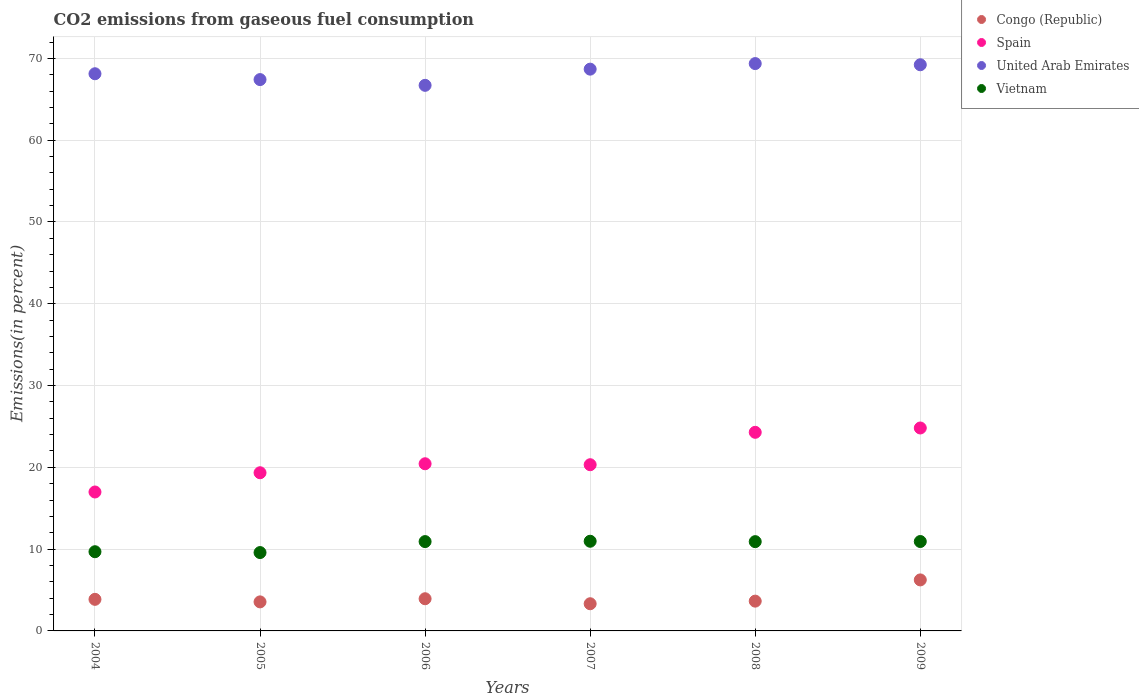What is the total CO2 emitted in Vietnam in 2006?
Your answer should be very brief. 10.92. Across all years, what is the maximum total CO2 emitted in Spain?
Your answer should be very brief. 24.81. Across all years, what is the minimum total CO2 emitted in United Arab Emirates?
Offer a terse response. 66.7. In which year was the total CO2 emitted in United Arab Emirates minimum?
Keep it short and to the point. 2006. What is the total total CO2 emitted in Spain in the graph?
Your response must be concise. 126.17. What is the difference between the total CO2 emitted in Spain in 2004 and that in 2009?
Keep it short and to the point. -7.83. What is the difference between the total CO2 emitted in Spain in 2006 and the total CO2 emitted in Vietnam in 2008?
Your answer should be very brief. 9.52. What is the average total CO2 emitted in Spain per year?
Give a very brief answer. 21.03. In the year 2008, what is the difference between the total CO2 emitted in Congo (Republic) and total CO2 emitted in United Arab Emirates?
Make the answer very short. -65.72. In how many years, is the total CO2 emitted in Congo (Republic) greater than 56 %?
Give a very brief answer. 0. What is the ratio of the total CO2 emitted in Congo (Republic) in 2007 to that in 2008?
Give a very brief answer. 0.91. What is the difference between the highest and the second highest total CO2 emitted in Vietnam?
Provide a short and direct response. 0.03. What is the difference between the highest and the lowest total CO2 emitted in Spain?
Offer a very short reply. 7.83. Is the sum of the total CO2 emitted in Congo (Republic) in 2006 and 2008 greater than the maximum total CO2 emitted in United Arab Emirates across all years?
Ensure brevity in your answer.  No. Is it the case that in every year, the sum of the total CO2 emitted in Vietnam and total CO2 emitted in Spain  is greater than the sum of total CO2 emitted in Congo (Republic) and total CO2 emitted in United Arab Emirates?
Your response must be concise. No. Does the total CO2 emitted in Congo (Republic) monotonically increase over the years?
Offer a terse response. No. Is the total CO2 emitted in Congo (Republic) strictly less than the total CO2 emitted in United Arab Emirates over the years?
Your answer should be very brief. Yes. How many years are there in the graph?
Ensure brevity in your answer.  6. What is the difference between two consecutive major ticks on the Y-axis?
Keep it short and to the point. 10. Does the graph contain grids?
Make the answer very short. Yes. How many legend labels are there?
Make the answer very short. 4. What is the title of the graph?
Provide a short and direct response. CO2 emissions from gaseous fuel consumption. What is the label or title of the Y-axis?
Make the answer very short. Emissions(in percent). What is the Emissions(in percent) in Congo (Republic) in 2004?
Keep it short and to the point. 3.86. What is the Emissions(in percent) of Spain in 2004?
Make the answer very short. 16.99. What is the Emissions(in percent) of United Arab Emirates in 2004?
Your answer should be very brief. 68.12. What is the Emissions(in percent) of Vietnam in 2004?
Give a very brief answer. 9.68. What is the Emissions(in percent) in Congo (Republic) in 2005?
Your answer should be very brief. 3.55. What is the Emissions(in percent) of Spain in 2005?
Provide a short and direct response. 19.34. What is the Emissions(in percent) of United Arab Emirates in 2005?
Keep it short and to the point. 67.41. What is the Emissions(in percent) of Vietnam in 2005?
Your response must be concise. 9.58. What is the Emissions(in percent) of Congo (Republic) in 2006?
Your response must be concise. 3.93. What is the Emissions(in percent) of Spain in 2006?
Your response must be concise. 20.44. What is the Emissions(in percent) of United Arab Emirates in 2006?
Provide a short and direct response. 66.7. What is the Emissions(in percent) of Vietnam in 2006?
Your response must be concise. 10.92. What is the Emissions(in percent) of Congo (Republic) in 2007?
Your answer should be compact. 3.32. What is the Emissions(in percent) in Spain in 2007?
Keep it short and to the point. 20.32. What is the Emissions(in percent) of United Arab Emirates in 2007?
Provide a short and direct response. 68.68. What is the Emissions(in percent) of Vietnam in 2007?
Your response must be concise. 10.96. What is the Emissions(in percent) of Congo (Republic) in 2008?
Keep it short and to the point. 3.64. What is the Emissions(in percent) of Spain in 2008?
Your response must be concise. 24.28. What is the Emissions(in percent) in United Arab Emirates in 2008?
Keep it short and to the point. 69.36. What is the Emissions(in percent) of Vietnam in 2008?
Offer a very short reply. 10.91. What is the Emissions(in percent) in Congo (Republic) in 2009?
Your answer should be very brief. 6.24. What is the Emissions(in percent) of Spain in 2009?
Offer a terse response. 24.81. What is the Emissions(in percent) of United Arab Emirates in 2009?
Offer a terse response. 69.22. What is the Emissions(in percent) in Vietnam in 2009?
Make the answer very short. 10.93. Across all years, what is the maximum Emissions(in percent) of Congo (Republic)?
Give a very brief answer. 6.24. Across all years, what is the maximum Emissions(in percent) in Spain?
Your response must be concise. 24.81. Across all years, what is the maximum Emissions(in percent) in United Arab Emirates?
Offer a terse response. 69.36. Across all years, what is the maximum Emissions(in percent) in Vietnam?
Make the answer very short. 10.96. Across all years, what is the minimum Emissions(in percent) of Congo (Republic)?
Your answer should be compact. 3.32. Across all years, what is the minimum Emissions(in percent) in Spain?
Provide a short and direct response. 16.99. Across all years, what is the minimum Emissions(in percent) in United Arab Emirates?
Your response must be concise. 66.7. Across all years, what is the minimum Emissions(in percent) of Vietnam?
Ensure brevity in your answer.  9.58. What is the total Emissions(in percent) in Congo (Republic) in the graph?
Offer a terse response. 24.55. What is the total Emissions(in percent) of Spain in the graph?
Your answer should be compact. 126.17. What is the total Emissions(in percent) of United Arab Emirates in the graph?
Offer a very short reply. 409.49. What is the total Emissions(in percent) of Vietnam in the graph?
Your response must be concise. 62.99. What is the difference between the Emissions(in percent) of Congo (Republic) in 2004 and that in 2005?
Make the answer very short. 0.31. What is the difference between the Emissions(in percent) in Spain in 2004 and that in 2005?
Provide a succinct answer. -2.35. What is the difference between the Emissions(in percent) of United Arab Emirates in 2004 and that in 2005?
Ensure brevity in your answer.  0.71. What is the difference between the Emissions(in percent) of Vietnam in 2004 and that in 2005?
Provide a short and direct response. 0.1. What is the difference between the Emissions(in percent) in Congo (Republic) in 2004 and that in 2006?
Your response must be concise. -0.07. What is the difference between the Emissions(in percent) of Spain in 2004 and that in 2006?
Your answer should be compact. -3.45. What is the difference between the Emissions(in percent) in United Arab Emirates in 2004 and that in 2006?
Give a very brief answer. 1.42. What is the difference between the Emissions(in percent) in Vietnam in 2004 and that in 2006?
Offer a terse response. -1.24. What is the difference between the Emissions(in percent) of Congo (Republic) in 2004 and that in 2007?
Your answer should be very brief. 0.54. What is the difference between the Emissions(in percent) of Spain in 2004 and that in 2007?
Keep it short and to the point. -3.33. What is the difference between the Emissions(in percent) of United Arab Emirates in 2004 and that in 2007?
Ensure brevity in your answer.  -0.56. What is the difference between the Emissions(in percent) of Vietnam in 2004 and that in 2007?
Offer a very short reply. -1.28. What is the difference between the Emissions(in percent) of Congo (Republic) in 2004 and that in 2008?
Ensure brevity in your answer.  0.22. What is the difference between the Emissions(in percent) of Spain in 2004 and that in 2008?
Give a very brief answer. -7.3. What is the difference between the Emissions(in percent) of United Arab Emirates in 2004 and that in 2008?
Your response must be concise. -1.24. What is the difference between the Emissions(in percent) of Vietnam in 2004 and that in 2008?
Offer a very short reply. -1.23. What is the difference between the Emissions(in percent) of Congo (Republic) in 2004 and that in 2009?
Offer a very short reply. -2.38. What is the difference between the Emissions(in percent) of Spain in 2004 and that in 2009?
Your answer should be compact. -7.83. What is the difference between the Emissions(in percent) of United Arab Emirates in 2004 and that in 2009?
Offer a very short reply. -1.1. What is the difference between the Emissions(in percent) in Vietnam in 2004 and that in 2009?
Offer a terse response. -1.25. What is the difference between the Emissions(in percent) of Congo (Republic) in 2005 and that in 2006?
Provide a short and direct response. -0.38. What is the difference between the Emissions(in percent) in Spain in 2005 and that in 2006?
Give a very brief answer. -1.1. What is the difference between the Emissions(in percent) in United Arab Emirates in 2005 and that in 2006?
Keep it short and to the point. 0.7. What is the difference between the Emissions(in percent) of Vietnam in 2005 and that in 2006?
Provide a short and direct response. -1.34. What is the difference between the Emissions(in percent) in Congo (Republic) in 2005 and that in 2007?
Keep it short and to the point. 0.23. What is the difference between the Emissions(in percent) in Spain in 2005 and that in 2007?
Your answer should be compact. -0.98. What is the difference between the Emissions(in percent) in United Arab Emirates in 2005 and that in 2007?
Make the answer very short. -1.28. What is the difference between the Emissions(in percent) in Vietnam in 2005 and that in 2007?
Your answer should be compact. -1.38. What is the difference between the Emissions(in percent) of Congo (Republic) in 2005 and that in 2008?
Your answer should be compact. -0.09. What is the difference between the Emissions(in percent) in Spain in 2005 and that in 2008?
Offer a terse response. -4.94. What is the difference between the Emissions(in percent) in United Arab Emirates in 2005 and that in 2008?
Make the answer very short. -1.96. What is the difference between the Emissions(in percent) in Vietnam in 2005 and that in 2008?
Give a very brief answer. -1.33. What is the difference between the Emissions(in percent) of Congo (Republic) in 2005 and that in 2009?
Your answer should be compact. -2.69. What is the difference between the Emissions(in percent) of Spain in 2005 and that in 2009?
Provide a short and direct response. -5.47. What is the difference between the Emissions(in percent) of United Arab Emirates in 2005 and that in 2009?
Keep it short and to the point. -1.81. What is the difference between the Emissions(in percent) in Vietnam in 2005 and that in 2009?
Provide a succinct answer. -1.35. What is the difference between the Emissions(in percent) of Congo (Republic) in 2006 and that in 2007?
Give a very brief answer. 0.61. What is the difference between the Emissions(in percent) in Spain in 2006 and that in 2007?
Your answer should be very brief. 0.12. What is the difference between the Emissions(in percent) in United Arab Emirates in 2006 and that in 2007?
Provide a succinct answer. -1.98. What is the difference between the Emissions(in percent) in Vietnam in 2006 and that in 2007?
Your answer should be compact. -0.04. What is the difference between the Emissions(in percent) in Congo (Republic) in 2006 and that in 2008?
Ensure brevity in your answer.  0.29. What is the difference between the Emissions(in percent) in Spain in 2006 and that in 2008?
Your answer should be compact. -3.85. What is the difference between the Emissions(in percent) of United Arab Emirates in 2006 and that in 2008?
Provide a succinct answer. -2.66. What is the difference between the Emissions(in percent) in Vietnam in 2006 and that in 2008?
Give a very brief answer. 0.01. What is the difference between the Emissions(in percent) of Congo (Republic) in 2006 and that in 2009?
Offer a terse response. -2.3. What is the difference between the Emissions(in percent) in Spain in 2006 and that in 2009?
Your answer should be compact. -4.37. What is the difference between the Emissions(in percent) of United Arab Emirates in 2006 and that in 2009?
Your response must be concise. -2.52. What is the difference between the Emissions(in percent) of Vietnam in 2006 and that in 2009?
Keep it short and to the point. -0.01. What is the difference between the Emissions(in percent) in Congo (Republic) in 2007 and that in 2008?
Keep it short and to the point. -0.32. What is the difference between the Emissions(in percent) of Spain in 2007 and that in 2008?
Ensure brevity in your answer.  -3.96. What is the difference between the Emissions(in percent) of United Arab Emirates in 2007 and that in 2008?
Make the answer very short. -0.68. What is the difference between the Emissions(in percent) of Vietnam in 2007 and that in 2008?
Offer a very short reply. 0.05. What is the difference between the Emissions(in percent) of Congo (Republic) in 2007 and that in 2009?
Provide a succinct answer. -2.91. What is the difference between the Emissions(in percent) in Spain in 2007 and that in 2009?
Make the answer very short. -4.49. What is the difference between the Emissions(in percent) in United Arab Emirates in 2007 and that in 2009?
Give a very brief answer. -0.54. What is the difference between the Emissions(in percent) in Vietnam in 2007 and that in 2009?
Your response must be concise. 0.03. What is the difference between the Emissions(in percent) of Congo (Republic) in 2008 and that in 2009?
Your response must be concise. -2.6. What is the difference between the Emissions(in percent) of Spain in 2008 and that in 2009?
Provide a succinct answer. -0.53. What is the difference between the Emissions(in percent) of United Arab Emirates in 2008 and that in 2009?
Offer a very short reply. 0.14. What is the difference between the Emissions(in percent) in Vietnam in 2008 and that in 2009?
Provide a short and direct response. -0.02. What is the difference between the Emissions(in percent) of Congo (Republic) in 2004 and the Emissions(in percent) of Spain in 2005?
Your response must be concise. -15.48. What is the difference between the Emissions(in percent) of Congo (Republic) in 2004 and the Emissions(in percent) of United Arab Emirates in 2005?
Your response must be concise. -63.54. What is the difference between the Emissions(in percent) in Congo (Republic) in 2004 and the Emissions(in percent) in Vietnam in 2005?
Provide a succinct answer. -5.72. What is the difference between the Emissions(in percent) in Spain in 2004 and the Emissions(in percent) in United Arab Emirates in 2005?
Your answer should be compact. -50.42. What is the difference between the Emissions(in percent) of Spain in 2004 and the Emissions(in percent) of Vietnam in 2005?
Offer a very short reply. 7.41. What is the difference between the Emissions(in percent) of United Arab Emirates in 2004 and the Emissions(in percent) of Vietnam in 2005?
Make the answer very short. 58.54. What is the difference between the Emissions(in percent) of Congo (Republic) in 2004 and the Emissions(in percent) of Spain in 2006?
Provide a succinct answer. -16.58. What is the difference between the Emissions(in percent) of Congo (Republic) in 2004 and the Emissions(in percent) of United Arab Emirates in 2006?
Provide a short and direct response. -62.84. What is the difference between the Emissions(in percent) of Congo (Republic) in 2004 and the Emissions(in percent) of Vietnam in 2006?
Give a very brief answer. -7.06. What is the difference between the Emissions(in percent) of Spain in 2004 and the Emissions(in percent) of United Arab Emirates in 2006?
Provide a succinct answer. -49.72. What is the difference between the Emissions(in percent) of Spain in 2004 and the Emissions(in percent) of Vietnam in 2006?
Keep it short and to the point. 6.06. What is the difference between the Emissions(in percent) in United Arab Emirates in 2004 and the Emissions(in percent) in Vietnam in 2006?
Provide a short and direct response. 57.2. What is the difference between the Emissions(in percent) in Congo (Republic) in 2004 and the Emissions(in percent) in Spain in 2007?
Your response must be concise. -16.46. What is the difference between the Emissions(in percent) in Congo (Republic) in 2004 and the Emissions(in percent) in United Arab Emirates in 2007?
Keep it short and to the point. -64.82. What is the difference between the Emissions(in percent) in Congo (Republic) in 2004 and the Emissions(in percent) in Vietnam in 2007?
Provide a short and direct response. -7.1. What is the difference between the Emissions(in percent) in Spain in 2004 and the Emissions(in percent) in United Arab Emirates in 2007?
Offer a very short reply. -51.7. What is the difference between the Emissions(in percent) in Spain in 2004 and the Emissions(in percent) in Vietnam in 2007?
Your response must be concise. 6.02. What is the difference between the Emissions(in percent) in United Arab Emirates in 2004 and the Emissions(in percent) in Vietnam in 2007?
Provide a succinct answer. 57.16. What is the difference between the Emissions(in percent) in Congo (Republic) in 2004 and the Emissions(in percent) in Spain in 2008?
Make the answer very short. -20.42. What is the difference between the Emissions(in percent) in Congo (Republic) in 2004 and the Emissions(in percent) in United Arab Emirates in 2008?
Your response must be concise. -65.5. What is the difference between the Emissions(in percent) of Congo (Republic) in 2004 and the Emissions(in percent) of Vietnam in 2008?
Ensure brevity in your answer.  -7.05. What is the difference between the Emissions(in percent) in Spain in 2004 and the Emissions(in percent) in United Arab Emirates in 2008?
Keep it short and to the point. -52.38. What is the difference between the Emissions(in percent) in Spain in 2004 and the Emissions(in percent) in Vietnam in 2008?
Provide a short and direct response. 6.07. What is the difference between the Emissions(in percent) in United Arab Emirates in 2004 and the Emissions(in percent) in Vietnam in 2008?
Make the answer very short. 57.2. What is the difference between the Emissions(in percent) in Congo (Republic) in 2004 and the Emissions(in percent) in Spain in 2009?
Provide a succinct answer. -20.95. What is the difference between the Emissions(in percent) of Congo (Republic) in 2004 and the Emissions(in percent) of United Arab Emirates in 2009?
Your answer should be very brief. -65.36. What is the difference between the Emissions(in percent) of Congo (Republic) in 2004 and the Emissions(in percent) of Vietnam in 2009?
Make the answer very short. -7.07. What is the difference between the Emissions(in percent) in Spain in 2004 and the Emissions(in percent) in United Arab Emirates in 2009?
Provide a succinct answer. -52.23. What is the difference between the Emissions(in percent) in Spain in 2004 and the Emissions(in percent) in Vietnam in 2009?
Offer a very short reply. 6.05. What is the difference between the Emissions(in percent) of United Arab Emirates in 2004 and the Emissions(in percent) of Vietnam in 2009?
Your response must be concise. 57.19. What is the difference between the Emissions(in percent) of Congo (Republic) in 2005 and the Emissions(in percent) of Spain in 2006?
Your response must be concise. -16.89. What is the difference between the Emissions(in percent) of Congo (Republic) in 2005 and the Emissions(in percent) of United Arab Emirates in 2006?
Provide a short and direct response. -63.15. What is the difference between the Emissions(in percent) of Congo (Republic) in 2005 and the Emissions(in percent) of Vietnam in 2006?
Keep it short and to the point. -7.37. What is the difference between the Emissions(in percent) in Spain in 2005 and the Emissions(in percent) in United Arab Emirates in 2006?
Ensure brevity in your answer.  -47.37. What is the difference between the Emissions(in percent) in Spain in 2005 and the Emissions(in percent) in Vietnam in 2006?
Offer a very short reply. 8.42. What is the difference between the Emissions(in percent) in United Arab Emirates in 2005 and the Emissions(in percent) in Vietnam in 2006?
Your response must be concise. 56.48. What is the difference between the Emissions(in percent) in Congo (Republic) in 2005 and the Emissions(in percent) in Spain in 2007?
Your answer should be compact. -16.77. What is the difference between the Emissions(in percent) in Congo (Republic) in 2005 and the Emissions(in percent) in United Arab Emirates in 2007?
Offer a very short reply. -65.13. What is the difference between the Emissions(in percent) in Congo (Republic) in 2005 and the Emissions(in percent) in Vietnam in 2007?
Offer a terse response. -7.41. What is the difference between the Emissions(in percent) in Spain in 2005 and the Emissions(in percent) in United Arab Emirates in 2007?
Offer a terse response. -49.34. What is the difference between the Emissions(in percent) in Spain in 2005 and the Emissions(in percent) in Vietnam in 2007?
Offer a terse response. 8.38. What is the difference between the Emissions(in percent) of United Arab Emirates in 2005 and the Emissions(in percent) of Vietnam in 2007?
Make the answer very short. 56.44. What is the difference between the Emissions(in percent) in Congo (Republic) in 2005 and the Emissions(in percent) in Spain in 2008?
Your answer should be compact. -20.73. What is the difference between the Emissions(in percent) of Congo (Republic) in 2005 and the Emissions(in percent) of United Arab Emirates in 2008?
Offer a very short reply. -65.81. What is the difference between the Emissions(in percent) of Congo (Republic) in 2005 and the Emissions(in percent) of Vietnam in 2008?
Give a very brief answer. -7.36. What is the difference between the Emissions(in percent) in Spain in 2005 and the Emissions(in percent) in United Arab Emirates in 2008?
Ensure brevity in your answer.  -50.02. What is the difference between the Emissions(in percent) in Spain in 2005 and the Emissions(in percent) in Vietnam in 2008?
Your answer should be compact. 8.42. What is the difference between the Emissions(in percent) of United Arab Emirates in 2005 and the Emissions(in percent) of Vietnam in 2008?
Offer a very short reply. 56.49. What is the difference between the Emissions(in percent) of Congo (Republic) in 2005 and the Emissions(in percent) of Spain in 2009?
Keep it short and to the point. -21.26. What is the difference between the Emissions(in percent) in Congo (Republic) in 2005 and the Emissions(in percent) in United Arab Emirates in 2009?
Provide a succinct answer. -65.67. What is the difference between the Emissions(in percent) of Congo (Republic) in 2005 and the Emissions(in percent) of Vietnam in 2009?
Offer a very short reply. -7.38. What is the difference between the Emissions(in percent) in Spain in 2005 and the Emissions(in percent) in United Arab Emirates in 2009?
Keep it short and to the point. -49.88. What is the difference between the Emissions(in percent) in Spain in 2005 and the Emissions(in percent) in Vietnam in 2009?
Your response must be concise. 8.41. What is the difference between the Emissions(in percent) in United Arab Emirates in 2005 and the Emissions(in percent) in Vietnam in 2009?
Keep it short and to the point. 56.47. What is the difference between the Emissions(in percent) in Congo (Republic) in 2006 and the Emissions(in percent) in Spain in 2007?
Your answer should be very brief. -16.39. What is the difference between the Emissions(in percent) in Congo (Republic) in 2006 and the Emissions(in percent) in United Arab Emirates in 2007?
Your response must be concise. -64.75. What is the difference between the Emissions(in percent) in Congo (Republic) in 2006 and the Emissions(in percent) in Vietnam in 2007?
Keep it short and to the point. -7.03. What is the difference between the Emissions(in percent) of Spain in 2006 and the Emissions(in percent) of United Arab Emirates in 2007?
Keep it short and to the point. -48.24. What is the difference between the Emissions(in percent) of Spain in 2006 and the Emissions(in percent) of Vietnam in 2007?
Your answer should be very brief. 9.47. What is the difference between the Emissions(in percent) in United Arab Emirates in 2006 and the Emissions(in percent) in Vietnam in 2007?
Provide a short and direct response. 55.74. What is the difference between the Emissions(in percent) of Congo (Republic) in 2006 and the Emissions(in percent) of Spain in 2008?
Provide a short and direct response. -20.35. What is the difference between the Emissions(in percent) in Congo (Republic) in 2006 and the Emissions(in percent) in United Arab Emirates in 2008?
Provide a short and direct response. -65.43. What is the difference between the Emissions(in percent) in Congo (Republic) in 2006 and the Emissions(in percent) in Vietnam in 2008?
Give a very brief answer. -6.98. What is the difference between the Emissions(in percent) in Spain in 2006 and the Emissions(in percent) in United Arab Emirates in 2008?
Provide a succinct answer. -48.93. What is the difference between the Emissions(in percent) of Spain in 2006 and the Emissions(in percent) of Vietnam in 2008?
Provide a succinct answer. 9.52. What is the difference between the Emissions(in percent) of United Arab Emirates in 2006 and the Emissions(in percent) of Vietnam in 2008?
Offer a very short reply. 55.79. What is the difference between the Emissions(in percent) in Congo (Republic) in 2006 and the Emissions(in percent) in Spain in 2009?
Provide a short and direct response. -20.88. What is the difference between the Emissions(in percent) of Congo (Republic) in 2006 and the Emissions(in percent) of United Arab Emirates in 2009?
Your response must be concise. -65.28. What is the difference between the Emissions(in percent) in Congo (Republic) in 2006 and the Emissions(in percent) in Vietnam in 2009?
Keep it short and to the point. -7. What is the difference between the Emissions(in percent) of Spain in 2006 and the Emissions(in percent) of United Arab Emirates in 2009?
Keep it short and to the point. -48.78. What is the difference between the Emissions(in percent) in Spain in 2006 and the Emissions(in percent) in Vietnam in 2009?
Your response must be concise. 9.51. What is the difference between the Emissions(in percent) of United Arab Emirates in 2006 and the Emissions(in percent) of Vietnam in 2009?
Keep it short and to the point. 55.77. What is the difference between the Emissions(in percent) in Congo (Republic) in 2007 and the Emissions(in percent) in Spain in 2008?
Your answer should be compact. -20.96. What is the difference between the Emissions(in percent) of Congo (Republic) in 2007 and the Emissions(in percent) of United Arab Emirates in 2008?
Offer a very short reply. -66.04. What is the difference between the Emissions(in percent) in Congo (Republic) in 2007 and the Emissions(in percent) in Vietnam in 2008?
Offer a very short reply. -7.59. What is the difference between the Emissions(in percent) of Spain in 2007 and the Emissions(in percent) of United Arab Emirates in 2008?
Offer a terse response. -49.04. What is the difference between the Emissions(in percent) in Spain in 2007 and the Emissions(in percent) in Vietnam in 2008?
Your response must be concise. 9.41. What is the difference between the Emissions(in percent) in United Arab Emirates in 2007 and the Emissions(in percent) in Vietnam in 2008?
Make the answer very short. 57.77. What is the difference between the Emissions(in percent) of Congo (Republic) in 2007 and the Emissions(in percent) of Spain in 2009?
Provide a succinct answer. -21.49. What is the difference between the Emissions(in percent) of Congo (Republic) in 2007 and the Emissions(in percent) of United Arab Emirates in 2009?
Your answer should be compact. -65.9. What is the difference between the Emissions(in percent) in Congo (Republic) in 2007 and the Emissions(in percent) in Vietnam in 2009?
Provide a succinct answer. -7.61. What is the difference between the Emissions(in percent) of Spain in 2007 and the Emissions(in percent) of United Arab Emirates in 2009?
Provide a succinct answer. -48.9. What is the difference between the Emissions(in percent) in Spain in 2007 and the Emissions(in percent) in Vietnam in 2009?
Keep it short and to the point. 9.39. What is the difference between the Emissions(in percent) of United Arab Emirates in 2007 and the Emissions(in percent) of Vietnam in 2009?
Keep it short and to the point. 57.75. What is the difference between the Emissions(in percent) in Congo (Republic) in 2008 and the Emissions(in percent) in Spain in 2009?
Your answer should be compact. -21.17. What is the difference between the Emissions(in percent) of Congo (Republic) in 2008 and the Emissions(in percent) of United Arab Emirates in 2009?
Your answer should be compact. -65.58. What is the difference between the Emissions(in percent) in Congo (Republic) in 2008 and the Emissions(in percent) in Vietnam in 2009?
Your answer should be very brief. -7.29. What is the difference between the Emissions(in percent) of Spain in 2008 and the Emissions(in percent) of United Arab Emirates in 2009?
Offer a terse response. -44.94. What is the difference between the Emissions(in percent) in Spain in 2008 and the Emissions(in percent) in Vietnam in 2009?
Offer a terse response. 13.35. What is the difference between the Emissions(in percent) of United Arab Emirates in 2008 and the Emissions(in percent) of Vietnam in 2009?
Provide a succinct answer. 58.43. What is the average Emissions(in percent) of Congo (Republic) per year?
Keep it short and to the point. 4.09. What is the average Emissions(in percent) in Spain per year?
Your answer should be compact. 21.03. What is the average Emissions(in percent) in United Arab Emirates per year?
Provide a succinct answer. 68.25. What is the average Emissions(in percent) of Vietnam per year?
Your answer should be compact. 10.5. In the year 2004, what is the difference between the Emissions(in percent) of Congo (Republic) and Emissions(in percent) of Spain?
Keep it short and to the point. -13.12. In the year 2004, what is the difference between the Emissions(in percent) in Congo (Republic) and Emissions(in percent) in United Arab Emirates?
Make the answer very short. -64.26. In the year 2004, what is the difference between the Emissions(in percent) in Congo (Republic) and Emissions(in percent) in Vietnam?
Your answer should be very brief. -5.82. In the year 2004, what is the difference between the Emissions(in percent) of Spain and Emissions(in percent) of United Arab Emirates?
Provide a succinct answer. -51.13. In the year 2004, what is the difference between the Emissions(in percent) of Spain and Emissions(in percent) of Vietnam?
Keep it short and to the point. 7.3. In the year 2004, what is the difference between the Emissions(in percent) of United Arab Emirates and Emissions(in percent) of Vietnam?
Your answer should be very brief. 58.44. In the year 2005, what is the difference between the Emissions(in percent) of Congo (Republic) and Emissions(in percent) of Spain?
Provide a succinct answer. -15.79. In the year 2005, what is the difference between the Emissions(in percent) of Congo (Republic) and Emissions(in percent) of United Arab Emirates?
Give a very brief answer. -63.86. In the year 2005, what is the difference between the Emissions(in percent) of Congo (Republic) and Emissions(in percent) of Vietnam?
Ensure brevity in your answer.  -6.03. In the year 2005, what is the difference between the Emissions(in percent) of Spain and Emissions(in percent) of United Arab Emirates?
Keep it short and to the point. -48.07. In the year 2005, what is the difference between the Emissions(in percent) of Spain and Emissions(in percent) of Vietnam?
Your response must be concise. 9.76. In the year 2005, what is the difference between the Emissions(in percent) in United Arab Emirates and Emissions(in percent) in Vietnam?
Give a very brief answer. 57.83. In the year 2006, what is the difference between the Emissions(in percent) in Congo (Republic) and Emissions(in percent) in Spain?
Make the answer very short. -16.5. In the year 2006, what is the difference between the Emissions(in percent) in Congo (Republic) and Emissions(in percent) in United Arab Emirates?
Make the answer very short. -62.77. In the year 2006, what is the difference between the Emissions(in percent) of Congo (Republic) and Emissions(in percent) of Vietnam?
Provide a short and direct response. -6.99. In the year 2006, what is the difference between the Emissions(in percent) of Spain and Emissions(in percent) of United Arab Emirates?
Provide a succinct answer. -46.27. In the year 2006, what is the difference between the Emissions(in percent) in Spain and Emissions(in percent) in Vietnam?
Keep it short and to the point. 9.52. In the year 2006, what is the difference between the Emissions(in percent) in United Arab Emirates and Emissions(in percent) in Vietnam?
Your response must be concise. 55.78. In the year 2007, what is the difference between the Emissions(in percent) in Congo (Republic) and Emissions(in percent) in Spain?
Provide a short and direct response. -17. In the year 2007, what is the difference between the Emissions(in percent) of Congo (Republic) and Emissions(in percent) of United Arab Emirates?
Ensure brevity in your answer.  -65.36. In the year 2007, what is the difference between the Emissions(in percent) of Congo (Republic) and Emissions(in percent) of Vietnam?
Give a very brief answer. -7.64. In the year 2007, what is the difference between the Emissions(in percent) in Spain and Emissions(in percent) in United Arab Emirates?
Ensure brevity in your answer.  -48.36. In the year 2007, what is the difference between the Emissions(in percent) of Spain and Emissions(in percent) of Vietnam?
Provide a short and direct response. 9.36. In the year 2007, what is the difference between the Emissions(in percent) of United Arab Emirates and Emissions(in percent) of Vietnam?
Ensure brevity in your answer.  57.72. In the year 2008, what is the difference between the Emissions(in percent) of Congo (Republic) and Emissions(in percent) of Spain?
Offer a terse response. -20.64. In the year 2008, what is the difference between the Emissions(in percent) in Congo (Republic) and Emissions(in percent) in United Arab Emirates?
Make the answer very short. -65.72. In the year 2008, what is the difference between the Emissions(in percent) of Congo (Republic) and Emissions(in percent) of Vietnam?
Make the answer very short. -7.27. In the year 2008, what is the difference between the Emissions(in percent) of Spain and Emissions(in percent) of United Arab Emirates?
Provide a short and direct response. -45.08. In the year 2008, what is the difference between the Emissions(in percent) of Spain and Emissions(in percent) of Vietnam?
Provide a short and direct response. 13.37. In the year 2008, what is the difference between the Emissions(in percent) of United Arab Emirates and Emissions(in percent) of Vietnam?
Keep it short and to the point. 58.45. In the year 2009, what is the difference between the Emissions(in percent) of Congo (Republic) and Emissions(in percent) of Spain?
Ensure brevity in your answer.  -18.57. In the year 2009, what is the difference between the Emissions(in percent) in Congo (Republic) and Emissions(in percent) in United Arab Emirates?
Your response must be concise. -62.98. In the year 2009, what is the difference between the Emissions(in percent) of Congo (Republic) and Emissions(in percent) of Vietnam?
Provide a succinct answer. -4.69. In the year 2009, what is the difference between the Emissions(in percent) in Spain and Emissions(in percent) in United Arab Emirates?
Keep it short and to the point. -44.41. In the year 2009, what is the difference between the Emissions(in percent) in Spain and Emissions(in percent) in Vietnam?
Offer a terse response. 13.88. In the year 2009, what is the difference between the Emissions(in percent) in United Arab Emirates and Emissions(in percent) in Vietnam?
Offer a very short reply. 58.29. What is the ratio of the Emissions(in percent) in Congo (Republic) in 2004 to that in 2005?
Ensure brevity in your answer.  1.09. What is the ratio of the Emissions(in percent) in Spain in 2004 to that in 2005?
Provide a succinct answer. 0.88. What is the ratio of the Emissions(in percent) of United Arab Emirates in 2004 to that in 2005?
Your response must be concise. 1.01. What is the ratio of the Emissions(in percent) in Vietnam in 2004 to that in 2005?
Your response must be concise. 1.01. What is the ratio of the Emissions(in percent) in Congo (Republic) in 2004 to that in 2006?
Offer a very short reply. 0.98. What is the ratio of the Emissions(in percent) in Spain in 2004 to that in 2006?
Give a very brief answer. 0.83. What is the ratio of the Emissions(in percent) of United Arab Emirates in 2004 to that in 2006?
Your answer should be very brief. 1.02. What is the ratio of the Emissions(in percent) of Vietnam in 2004 to that in 2006?
Give a very brief answer. 0.89. What is the ratio of the Emissions(in percent) in Congo (Republic) in 2004 to that in 2007?
Keep it short and to the point. 1.16. What is the ratio of the Emissions(in percent) of Spain in 2004 to that in 2007?
Offer a terse response. 0.84. What is the ratio of the Emissions(in percent) of United Arab Emirates in 2004 to that in 2007?
Your response must be concise. 0.99. What is the ratio of the Emissions(in percent) in Vietnam in 2004 to that in 2007?
Offer a terse response. 0.88. What is the ratio of the Emissions(in percent) in Congo (Republic) in 2004 to that in 2008?
Keep it short and to the point. 1.06. What is the ratio of the Emissions(in percent) of Spain in 2004 to that in 2008?
Make the answer very short. 0.7. What is the ratio of the Emissions(in percent) in United Arab Emirates in 2004 to that in 2008?
Make the answer very short. 0.98. What is the ratio of the Emissions(in percent) of Vietnam in 2004 to that in 2008?
Make the answer very short. 0.89. What is the ratio of the Emissions(in percent) of Congo (Republic) in 2004 to that in 2009?
Your answer should be very brief. 0.62. What is the ratio of the Emissions(in percent) of Spain in 2004 to that in 2009?
Provide a short and direct response. 0.68. What is the ratio of the Emissions(in percent) of United Arab Emirates in 2004 to that in 2009?
Your answer should be compact. 0.98. What is the ratio of the Emissions(in percent) in Vietnam in 2004 to that in 2009?
Provide a short and direct response. 0.89. What is the ratio of the Emissions(in percent) in Congo (Republic) in 2005 to that in 2006?
Your answer should be compact. 0.9. What is the ratio of the Emissions(in percent) of Spain in 2005 to that in 2006?
Keep it short and to the point. 0.95. What is the ratio of the Emissions(in percent) of United Arab Emirates in 2005 to that in 2006?
Keep it short and to the point. 1.01. What is the ratio of the Emissions(in percent) in Vietnam in 2005 to that in 2006?
Offer a very short reply. 0.88. What is the ratio of the Emissions(in percent) in Congo (Republic) in 2005 to that in 2007?
Your response must be concise. 1.07. What is the ratio of the Emissions(in percent) of Spain in 2005 to that in 2007?
Provide a short and direct response. 0.95. What is the ratio of the Emissions(in percent) in United Arab Emirates in 2005 to that in 2007?
Your response must be concise. 0.98. What is the ratio of the Emissions(in percent) in Vietnam in 2005 to that in 2007?
Make the answer very short. 0.87. What is the ratio of the Emissions(in percent) in Spain in 2005 to that in 2008?
Your answer should be very brief. 0.8. What is the ratio of the Emissions(in percent) in United Arab Emirates in 2005 to that in 2008?
Your response must be concise. 0.97. What is the ratio of the Emissions(in percent) of Vietnam in 2005 to that in 2008?
Offer a very short reply. 0.88. What is the ratio of the Emissions(in percent) in Congo (Republic) in 2005 to that in 2009?
Provide a short and direct response. 0.57. What is the ratio of the Emissions(in percent) in Spain in 2005 to that in 2009?
Provide a succinct answer. 0.78. What is the ratio of the Emissions(in percent) of United Arab Emirates in 2005 to that in 2009?
Ensure brevity in your answer.  0.97. What is the ratio of the Emissions(in percent) of Vietnam in 2005 to that in 2009?
Provide a succinct answer. 0.88. What is the ratio of the Emissions(in percent) in Congo (Republic) in 2006 to that in 2007?
Make the answer very short. 1.18. What is the ratio of the Emissions(in percent) of Spain in 2006 to that in 2007?
Provide a short and direct response. 1.01. What is the ratio of the Emissions(in percent) of United Arab Emirates in 2006 to that in 2007?
Your answer should be compact. 0.97. What is the ratio of the Emissions(in percent) in Congo (Republic) in 2006 to that in 2008?
Your response must be concise. 1.08. What is the ratio of the Emissions(in percent) in Spain in 2006 to that in 2008?
Provide a succinct answer. 0.84. What is the ratio of the Emissions(in percent) in United Arab Emirates in 2006 to that in 2008?
Provide a short and direct response. 0.96. What is the ratio of the Emissions(in percent) in Vietnam in 2006 to that in 2008?
Your answer should be very brief. 1. What is the ratio of the Emissions(in percent) in Congo (Republic) in 2006 to that in 2009?
Offer a terse response. 0.63. What is the ratio of the Emissions(in percent) in Spain in 2006 to that in 2009?
Your answer should be compact. 0.82. What is the ratio of the Emissions(in percent) in United Arab Emirates in 2006 to that in 2009?
Keep it short and to the point. 0.96. What is the ratio of the Emissions(in percent) of Vietnam in 2006 to that in 2009?
Your answer should be compact. 1. What is the ratio of the Emissions(in percent) of Congo (Republic) in 2007 to that in 2008?
Make the answer very short. 0.91. What is the ratio of the Emissions(in percent) in Spain in 2007 to that in 2008?
Provide a succinct answer. 0.84. What is the ratio of the Emissions(in percent) of United Arab Emirates in 2007 to that in 2008?
Keep it short and to the point. 0.99. What is the ratio of the Emissions(in percent) in Vietnam in 2007 to that in 2008?
Give a very brief answer. 1. What is the ratio of the Emissions(in percent) of Congo (Republic) in 2007 to that in 2009?
Keep it short and to the point. 0.53. What is the ratio of the Emissions(in percent) of Spain in 2007 to that in 2009?
Offer a terse response. 0.82. What is the ratio of the Emissions(in percent) of United Arab Emirates in 2007 to that in 2009?
Your answer should be compact. 0.99. What is the ratio of the Emissions(in percent) in Congo (Republic) in 2008 to that in 2009?
Keep it short and to the point. 0.58. What is the ratio of the Emissions(in percent) of Spain in 2008 to that in 2009?
Offer a very short reply. 0.98. What is the difference between the highest and the second highest Emissions(in percent) of Congo (Republic)?
Your answer should be compact. 2.3. What is the difference between the highest and the second highest Emissions(in percent) in Spain?
Offer a very short reply. 0.53. What is the difference between the highest and the second highest Emissions(in percent) of United Arab Emirates?
Give a very brief answer. 0.14. What is the difference between the highest and the second highest Emissions(in percent) of Vietnam?
Your answer should be very brief. 0.03. What is the difference between the highest and the lowest Emissions(in percent) of Congo (Republic)?
Make the answer very short. 2.91. What is the difference between the highest and the lowest Emissions(in percent) in Spain?
Your answer should be very brief. 7.83. What is the difference between the highest and the lowest Emissions(in percent) of United Arab Emirates?
Make the answer very short. 2.66. What is the difference between the highest and the lowest Emissions(in percent) in Vietnam?
Provide a succinct answer. 1.38. 